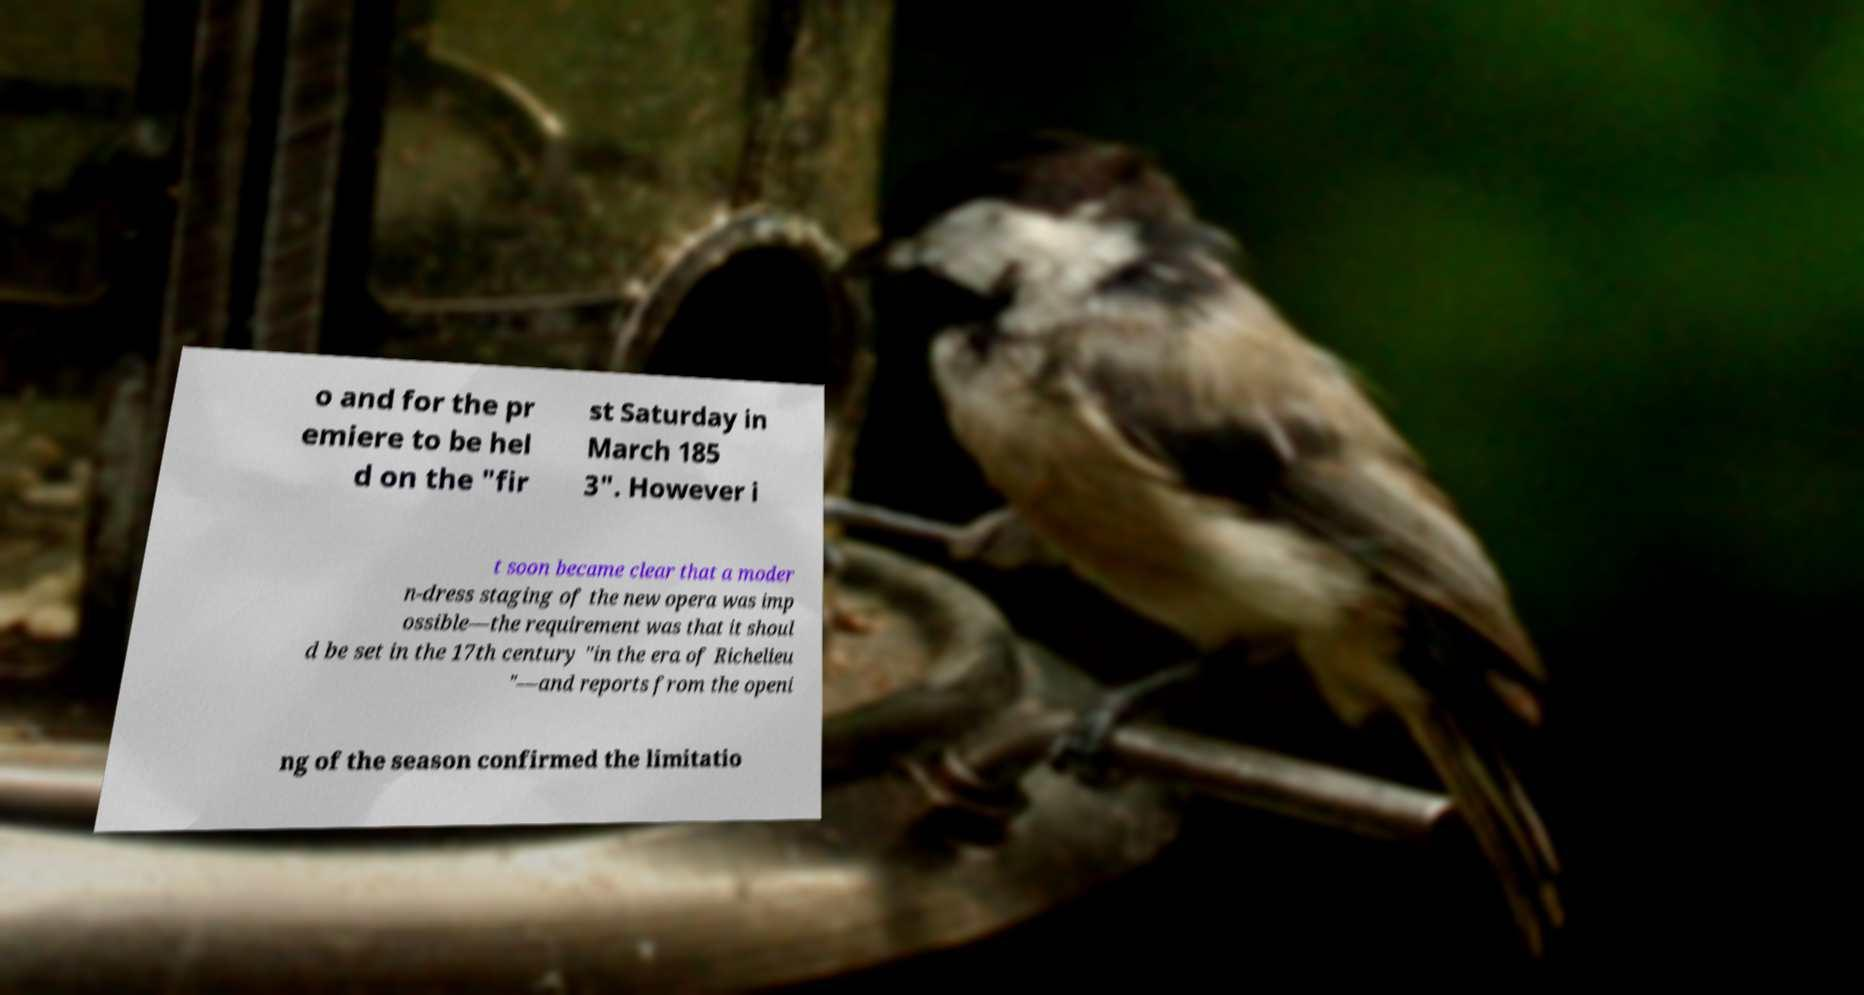Could you assist in decoding the text presented in this image and type it out clearly? o and for the pr emiere to be hel d on the "fir st Saturday in March 185 3". However i t soon became clear that a moder n-dress staging of the new opera was imp ossible—the requirement was that it shoul d be set in the 17th century "in the era of Richelieu "—and reports from the openi ng of the season confirmed the limitatio 